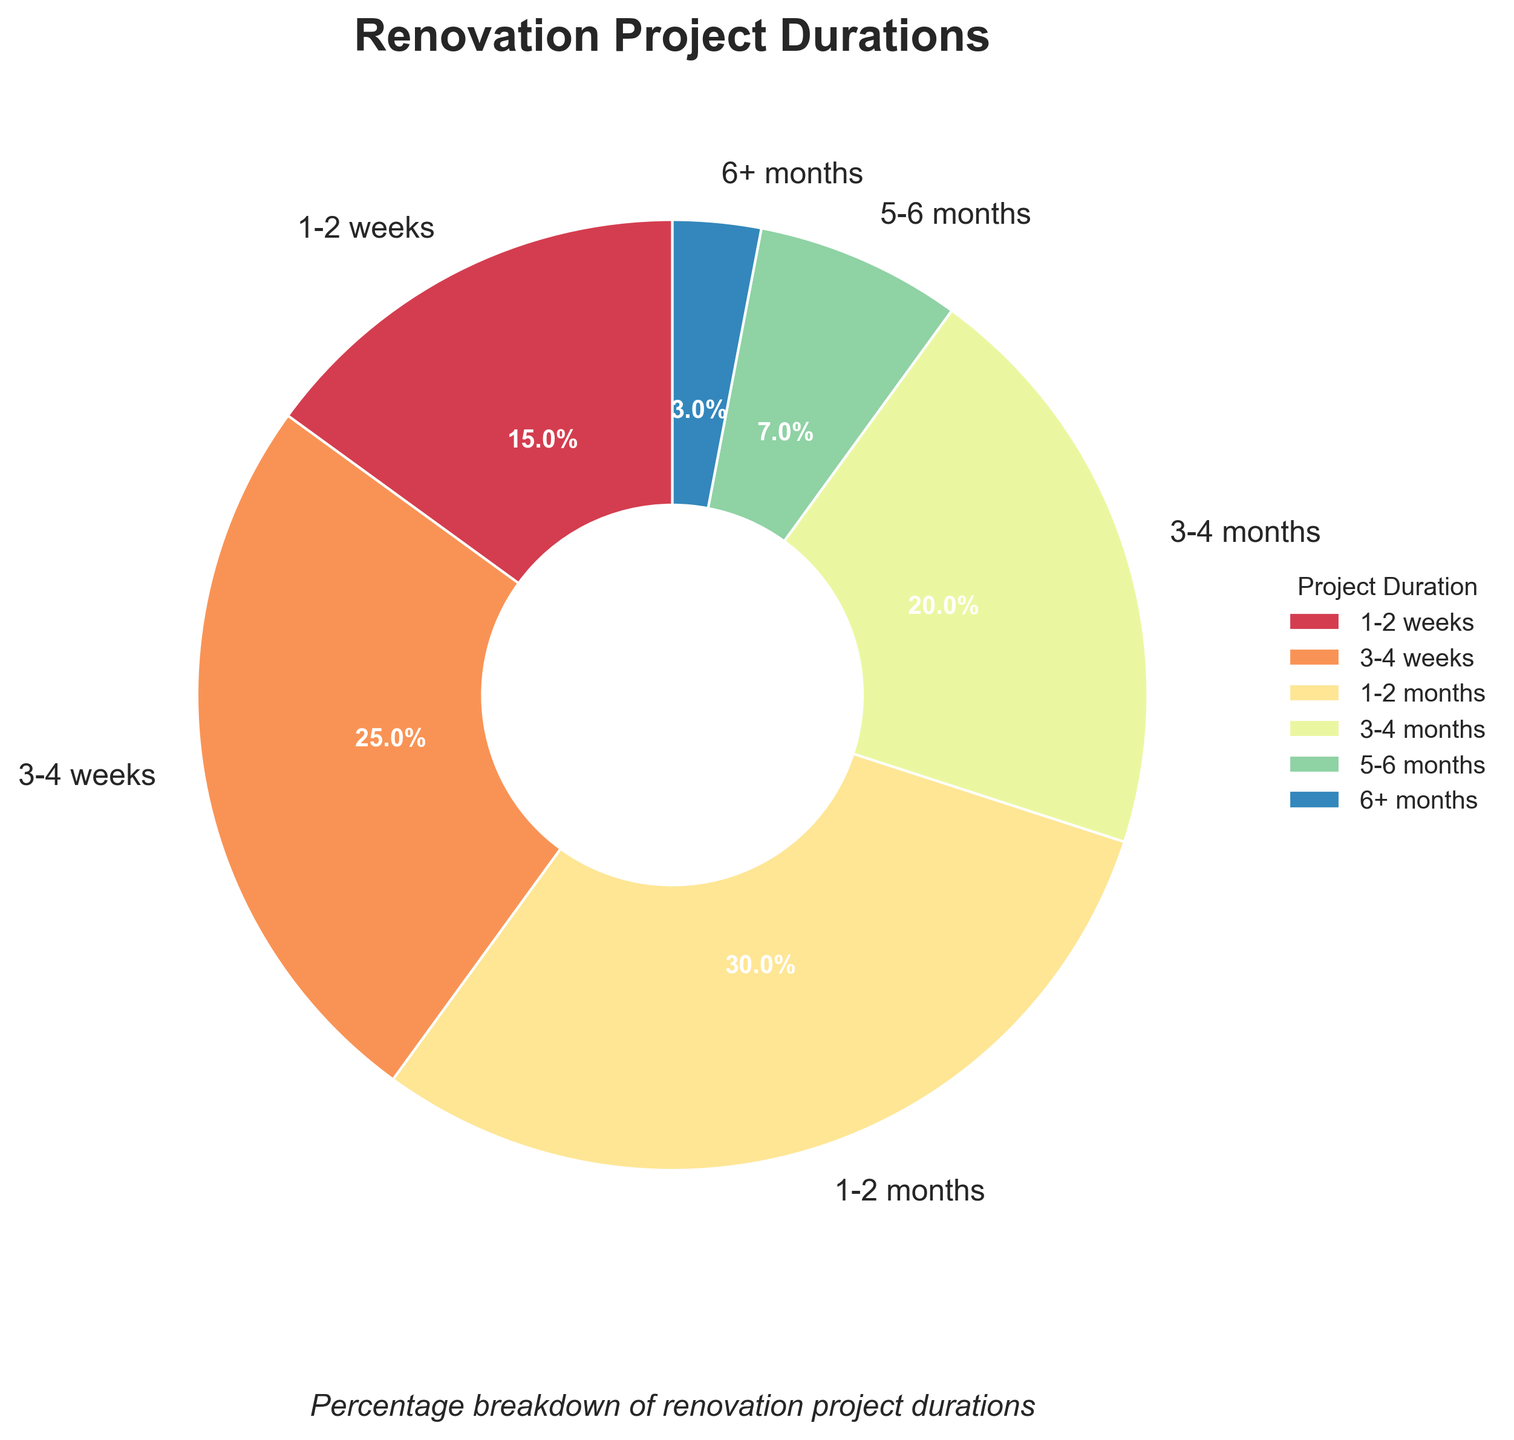Which project duration has the highest percentage? The segment representing "1-2 months" is the largest slice of the pie chart, indicating it has the highest percentage.
Answer: 1-2 months What's the combined percentage of projects lasting 1-2 months and 3-4 weeks? Add the percentages for "1-2 months" (30%) and "3-4 weeks" (25%): 30 + 25 = 55
Answer: 55 Which project duration is more frequent: 5-6 months or 6+ months? Compare the slices for "5-6 months" (7%) and "6+ months" (3%). The "5-6 months" slice is larger.
Answer: 5-6 months How much more frequent are projects lasting 1-2 weeks compared to projects lasting 5-6 months? Subtract the percentage of "5-6 months" (7%) from the percentage of "1-2 weeks" (15%): 15 - 7 = 8
Answer: 8 What is the average percentage of projects lasting between 1-2 months, 3-4 months, and 6+ months? Add the percentages for "1-2 months" (30%), "3-4 months" (20%), and "6+ months" (3%) and divide by 3: (30 + 20 + 3) / 3 = 17.67
Answer: 17.67 Describe the color of the slice representing 3-4 weeks. The slice representing "3-4 weeks" is colored with one of the shades from the Spectral color palette used in the pie chart; typically, a vibrant and distinguishable shade.
Answer: Vibrant shade Are there more projects lasting less than a month or more than 3 months? Sum the percentages of durations less than a month (1-2 weeks: 15%, 3-4 weeks: 25%) and compare with the sum of durations more than 3 months (3-4 months: 20%, 5-6 months: 7%, 6+ months: 3%). Less than a month: 15 + 25 = 40; More than 3 months: 20 + 7 + 3 = 30.
Answer: Less than a month What percentage of projects lasts more than 1 month but less than 3 months? Sum the percentages for "1-2 months" (30%) and "3-4 months" (20%): 30 + 20 = 50
Answer: 50 Which project duration has the smallest percentage, and what is that percentage? Identify the smallest slice on the pie chart, which is "6+ months" with 3%.
Answer: 6+ months, 3 If a new category "7-8 months" was added and it had a 2% share, what would be the new combined percentage for projects lasting more than 6 months? Add the 2% of "7-8 months" to the current 3% of "6+ months": 3 + 2 = 5
Answer: 5 